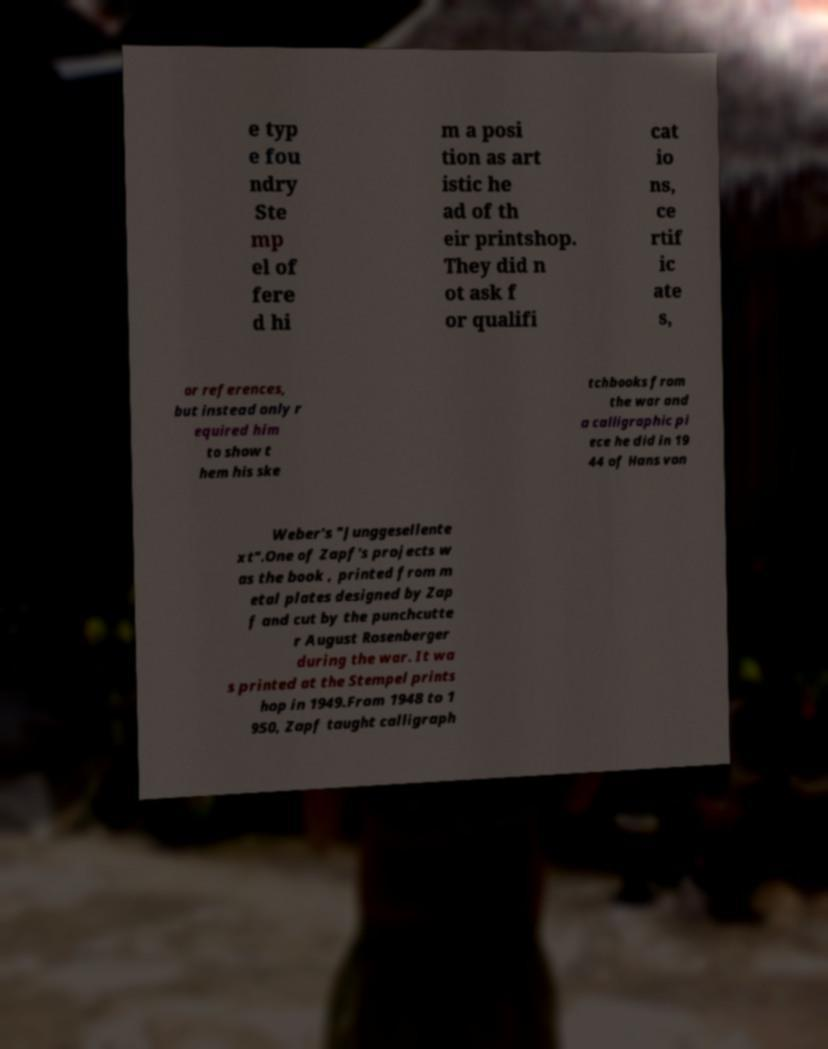Could you extract and type out the text from this image? e typ e fou ndry Ste mp el of fere d hi m a posi tion as art istic he ad of th eir printshop. They did n ot ask f or qualifi cat io ns, ce rtif ic ate s, or references, but instead only r equired him to show t hem his ske tchbooks from the war and a calligraphic pi ece he did in 19 44 of Hans von Weber's "Junggesellente xt".One of Zapf's projects w as the book , printed from m etal plates designed by Zap f and cut by the punchcutte r August Rosenberger during the war. It wa s printed at the Stempel prints hop in 1949.From 1948 to 1 950, Zapf taught calligraph 